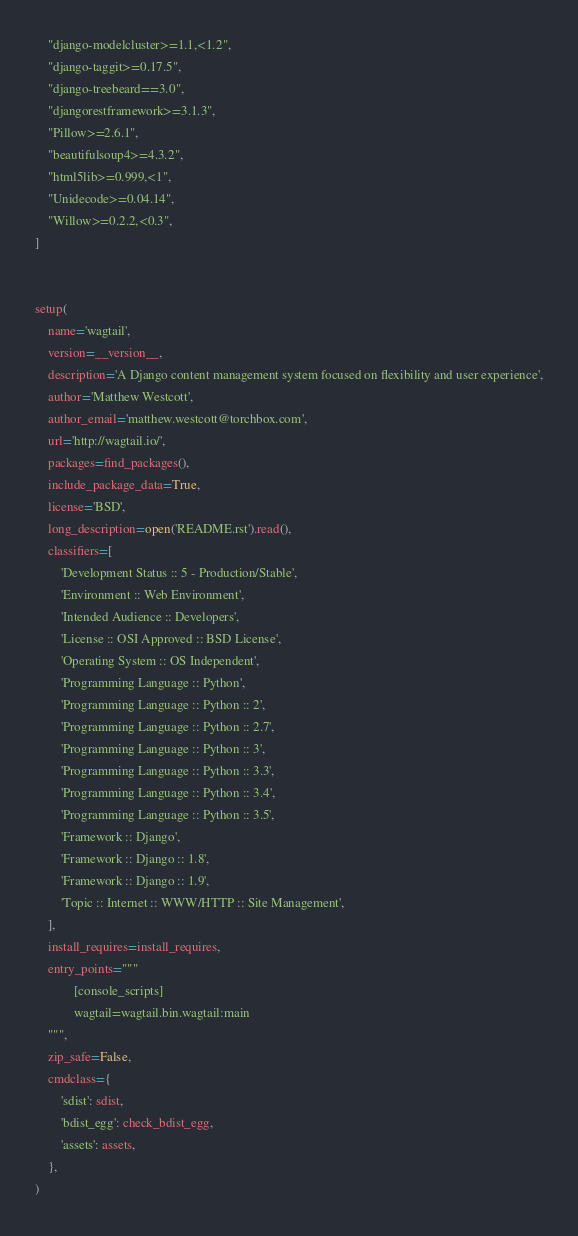<code> <loc_0><loc_0><loc_500><loc_500><_Python_>    "django-modelcluster>=1.1,<1.2",
    "django-taggit>=0.17.5",
    "django-treebeard==3.0",
    "djangorestframework>=3.1.3",
    "Pillow>=2.6.1",
    "beautifulsoup4>=4.3.2",
    "html5lib>=0.999,<1",
    "Unidecode>=0.04.14",
    "Willow>=0.2.2,<0.3",
]


setup(
    name='wagtail',
    version=__version__,
    description='A Django content management system focused on flexibility and user experience',
    author='Matthew Westcott',
    author_email='matthew.westcott@torchbox.com',
    url='http://wagtail.io/',
    packages=find_packages(),
    include_package_data=True,
    license='BSD',
    long_description=open('README.rst').read(),
    classifiers=[
        'Development Status :: 5 - Production/Stable',
        'Environment :: Web Environment',
        'Intended Audience :: Developers',
        'License :: OSI Approved :: BSD License',
        'Operating System :: OS Independent',
        'Programming Language :: Python',
        'Programming Language :: Python :: 2',
        'Programming Language :: Python :: 2.7',
        'Programming Language :: Python :: 3',
        'Programming Language :: Python :: 3.3',
        'Programming Language :: Python :: 3.4',
        'Programming Language :: Python :: 3.5',
        'Framework :: Django',
        'Framework :: Django :: 1.8',
        'Framework :: Django :: 1.9',
        'Topic :: Internet :: WWW/HTTP :: Site Management',
    ],
    install_requires=install_requires,
    entry_points="""
            [console_scripts]
            wagtail=wagtail.bin.wagtail:main
    """,
    zip_safe=False,
    cmdclass={
        'sdist': sdist,
        'bdist_egg': check_bdist_egg,
        'assets': assets,
    },
)
</code> 